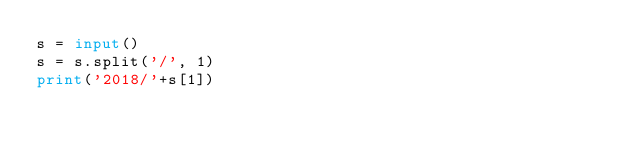Convert code to text. <code><loc_0><loc_0><loc_500><loc_500><_Python_>s = input()
s = s.split('/', 1)
print('2018/'+s[1])</code> 